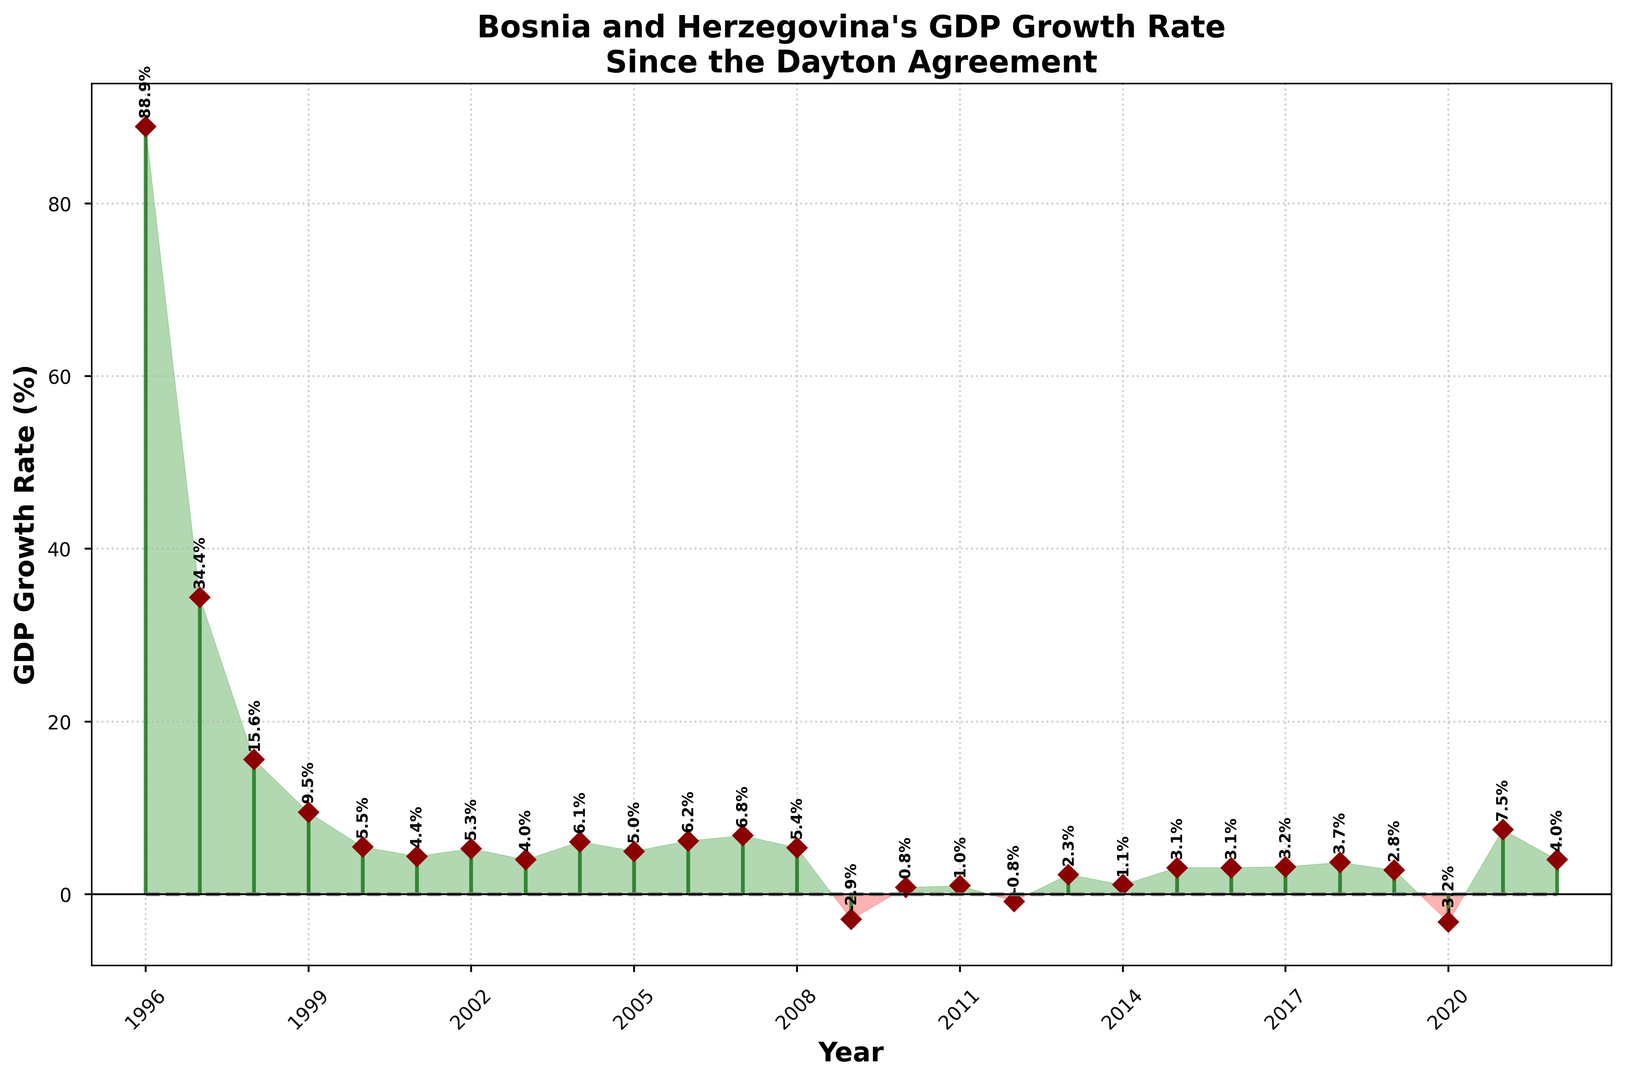What is the highest GDP growth rate shown in the figure? The highest GDP growth rate can be identified by looking at the tallest vertical line in the plot, which occurs in 1996. The value at the top of this line is 88.9%.
Answer: 88.9% How many times did Bosnia and Herzegovina experience a negative GDP growth rate? A negative GDP growth rate is represented by the lines extending below the zero horizontal line. From the figure, this occurs in 2009, 2012, and 2020. Counting these, we find there are 3 instances.
Answer: 3 Which year showed the lowest GDP growth rate, and what was the rate? The lowest GDP growth rate will have the deepest "red" stem extending downward. This occurs in 2020 with a rate of -3.2%.
Answer: 2020, -3.2% How did the GDP growth rate change from 2008 to 2009? To determine the change, observe the height difference between the lines for 2008 and 2009. In 2008, the rate was 5.4%, and in 2009, it dropped to -2.9%. The change is 5.4% - (-2.9%) = 8.3%.
Answer: Decreased by 8.3% What is the average GDP growth rate over the period shown in the figure? To calculate the average, sum all the GDP growth rates and divide by the number of years. The sum is 235.7 and there are 27 years represented. Thus, the average is 235.7 / 27 ≈ 8.73%.
Answer: 8.73% Which three years experienced the highest positive GDP growth rates after 1996? Excluding 1996, the next highest rates can be identified visually by the tallest remaining "green" stems. These are in 1997 (34.4%), 1998 (15.6%), and 1999 (9.5%).
Answer: 1997, 1998, 1999 In which years was the GDP growth rate greater than 6%? Looking at the green stems that are taller than 6 on the Y-axis, these years are 1996, 1997, 1998, 1999, 2007, 2006, and 2021.
Answer: 1996, 1997, 1998, 1999, 2007, 2006, 2021 What is the overall trend in the GDP growth rate from 2010 to 2014? Observing the consecutive years from 2010 to 2014, the GDP growth rates are 0.8%, 1.0%, -0.8%, 2.3%, and 1.1%, respectively. The trend shows fluctuating but gradually increasing rates.
Answer: Increasing trend 